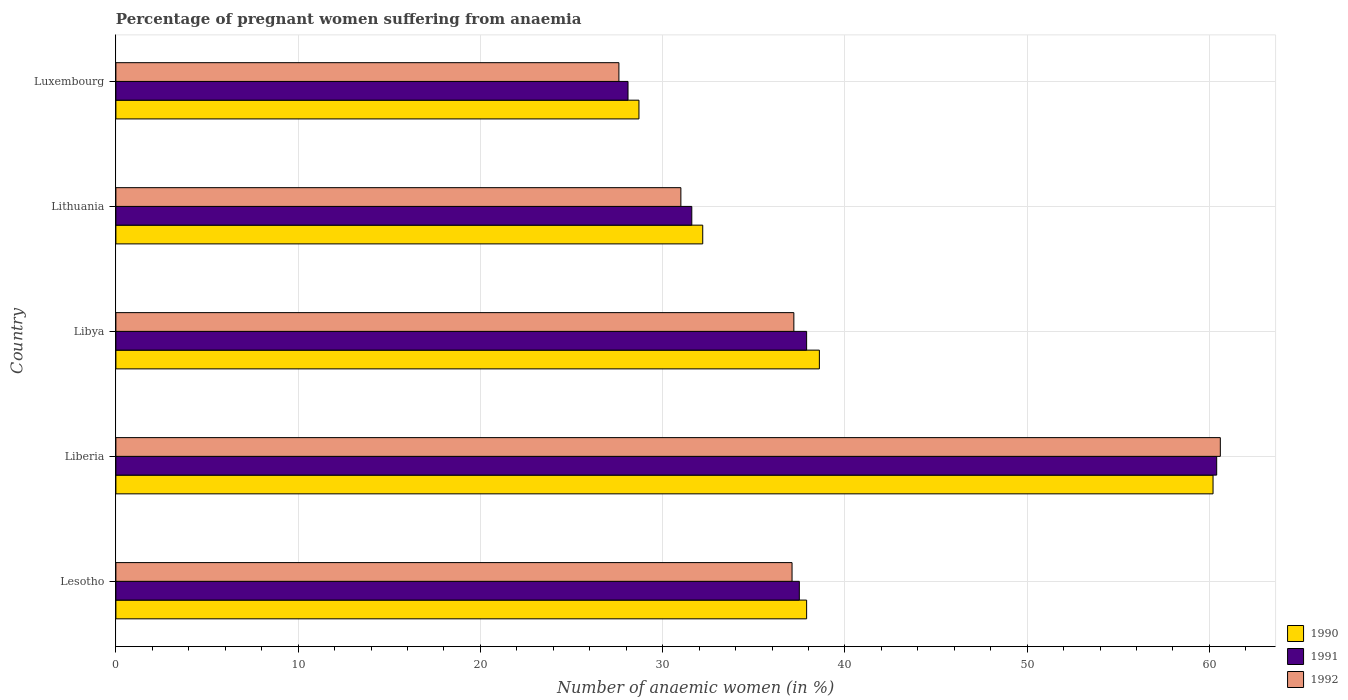How many different coloured bars are there?
Your answer should be compact. 3. How many groups of bars are there?
Provide a short and direct response. 5. How many bars are there on the 1st tick from the bottom?
Provide a short and direct response. 3. What is the label of the 1st group of bars from the top?
Offer a very short reply. Luxembourg. What is the number of anaemic women in 1991 in Lithuania?
Keep it short and to the point. 31.6. Across all countries, what is the maximum number of anaemic women in 1990?
Keep it short and to the point. 60.2. Across all countries, what is the minimum number of anaemic women in 1990?
Offer a terse response. 28.7. In which country was the number of anaemic women in 1991 maximum?
Make the answer very short. Liberia. In which country was the number of anaemic women in 1992 minimum?
Your answer should be very brief. Luxembourg. What is the total number of anaemic women in 1991 in the graph?
Make the answer very short. 195.5. What is the difference between the number of anaemic women in 1991 in Lesotho and that in Liberia?
Provide a succinct answer. -22.9. What is the difference between the number of anaemic women in 1990 in Libya and the number of anaemic women in 1992 in Lithuania?
Provide a short and direct response. 7.6. What is the average number of anaemic women in 1991 per country?
Ensure brevity in your answer.  39.1. What is the difference between the number of anaemic women in 1991 and number of anaemic women in 1990 in Lesotho?
Your answer should be compact. -0.4. What is the ratio of the number of anaemic women in 1991 in Lithuania to that in Luxembourg?
Offer a very short reply. 1.12. What is the difference between the highest and the second highest number of anaemic women in 1990?
Your answer should be very brief. 21.6. What is the difference between the highest and the lowest number of anaemic women in 1990?
Give a very brief answer. 31.5. What does the 1st bar from the top in Liberia represents?
Make the answer very short. 1992. Are all the bars in the graph horizontal?
Your answer should be very brief. Yes. Are the values on the major ticks of X-axis written in scientific E-notation?
Keep it short and to the point. No. How many legend labels are there?
Give a very brief answer. 3. What is the title of the graph?
Offer a very short reply. Percentage of pregnant women suffering from anaemia. Does "1976" appear as one of the legend labels in the graph?
Your response must be concise. No. What is the label or title of the X-axis?
Provide a short and direct response. Number of anaemic women (in %). What is the Number of anaemic women (in %) in 1990 in Lesotho?
Offer a terse response. 37.9. What is the Number of anaemic women (in %) in 1991 in Lesotho?
Provide a succinct answer. 37.5. What is the Number of anaemic women (in %) in 1992 in Lesotho?
Make the answer very short. 37.1. What is the Number of anaemic women (in %) in 1990 in Liberia?
Give a very brief answer. 60.2. What is the Number of anaemic women (in %) in 1991 in Liberia?
Keep it short and to the point. 60.4. What is the Number of anaemic women (in %) in 1992 in Liberia?
Provide a short and direct response. 60.6. What is the Number of anaemic women (in %) of 1990 in Libya?
Give a very brief answer. 38.6. What is the Number of anaemic women (in %) of 1991 in Libya?
Give a very brief answer. 37.9. What is the Number of anaemic women (in %) in 1992 in Libya?
Keep it short and to the point. 37.2. What is the Number of anaemic women (in %) in 1990 in Lithuania?
Make the answer very short. 32.2. What is the Number of anaemic women (in %) of 1991 in Lithuania?
Offer a terse response. 31.6. What is the Number of anaemic women (in %) in 1992 in Lithuania?
Your answer should be compact. 31. What is the Number of anaemic women (in %) of 1990 in Luxembourg?
Give a very brief answer. 28.7. What is the Number of anaemic women (in %) in 1991 in Luxembourg?
Your answer should be very brief. 28.1. What is the Number of anaemic women (in %) in 1992 in Luxembourg?
Make the answer very short. 27.6. Across all countries, what is the maximum Number of anaemic women (in %) in 1990?
Your answer should be compact. 60.2. Across all countries, what is the maximum Number of anaemic women (in %) of 1991?
Your answer should be compact. 60.4. Across all countries, what is the maximum Number of anaemic women (in %) in 1992?
Provide a succinct answer. 60.6. Across all countries, what is the minimum Number of anaemic women (in %) of 1990?
Your answer should be compact. 28.7. Across all countries, what is the minimum Number of anaemic women (in %) in 1991?
Provide a succinct answer. 28.1. Across all countries, what is the minimum Number of anaemic women (in %) of 1992?
Keep it short and to the point. 27.6. What is the total Number of anaemic women (in %) in 1990 in the graph?
Ensure brevity in your answer.  197.6. What is the total Number of anaemic women (in %) in 1991 in the graph?
Your answer should be very brief. 195.5. What is the total Number of anaemic women (in %) in 1992 in the graph?
Keep it short and to the point. 193.5. What is the difference between the Number of anaemic women (in %) in 1990 in Lesotho and that in Liberia?
Give a very brief answer. -22.3. What is the difference between the Number of anaemic women (in %) of 1991 in Lesotho and that in Liberia?
Offer a very short reply. -22.9. What is the difference between the Number of anaemic women (in %) in 1992 in Lesotho and that in Liberia?
Your answer should be compact. -23.5. What is the difference between the Number of anaemic women (in %) in 1990 in Lesotho and that in Libya?
Offer a terse response. -0.7. What is the difference between the Number of anaemic women (in %) in 1991 in Lesotho and that in Libya?
Offer a very short reply. -0.4. What is the difference between the Number of anaemic women (in %) in 1990 in Lesotho and that in Lithuania?
Give a very brief answer. 5.7. What is the difference between the Number of anaemic women (in %) in 1992 in Lesotho and that in Lithuania?
Make the answer very short. 6.1. What is the difference between the Number of anaemic women (in %) in 1992 in Lesotho and that in Luxembourg?
Your response must be concise. 9.5. What is the difference between the Number of anaemic women (in %) of 1990 in Liberia and that in Libya?
Give a very brief answer. 21.6. What is the difference between the Number of anaemic women (in %) in 1991 in Liberia and that in Libya?
Ensure brevity in your answer.  22.5. What is the difference between the Number of anaemic women (in %) in 1992 in Liberia and that in Libya?
Ensure brevity in your answer.  23.4. What is the difference between the Number of anaemic women (in %) of 1991 in Liberia and that in Lithuania?
Your answer should be very brief. 28.8. What is the difference between the Number of anaemic women (in %) of 1992 in Liberia and that in Lithuania?
Keep it short and to the point. 29.6. What is the difference between the Number of anaemic women (in %) of 1990 in Liberia and that in Luxembourg?
Your answer should be very brief. 31.5. What is the difference between the Number of anaemic women (in %) in 1991 in Liberia and that in Luxembourg?
Make the answer very short. 32.3. What is the difference between the Number of anaemic women (in %) in 1991 in Libya and that in Lithuania?
Provide a short and direct response. 6.3. What is the difference between the Number of anaemic women (in %) of 1990 in Libya and that in Luxembourg?
Your response must be concise. 9.9. What is the difference between the Number of anaemic women (in %) in 1991 in Libya and that in Luxembourg?
Your response must be concise. 9.8. What is the difference between the Number of anaemic women (in %) of 1992 in Libya and that in Luxembourg?
Give a very brief answer. 9.6. What is the difference between the Number of anaemic women (in %) in 1990 in Lithuania and that in Luxembourg?
Your response must be concise. 3.5. What is the difference between the Number of anaemic women (in %) of 1992 in Lithuania and that in Luxembourg?
Offer a terse response. 3.4. What is the difference between the Number of anaemic women (in %) in 1990 in Lesotho and the Number of anaemic women (in %) in 1991 in Liberia?
Offer a very short reply. -22.5. What is the difference between the Number of anaemic women (in %) in 1990 in Lesotho and the Number of anaemic women (in %) in 1992 in Liberia?
Provide a short and direct response. -22.7. What is the difference between the Number of anaemic women (in %) in 1991 in Lesotho and the Number of anaemic women (in %) in 1992 in Liberia?
Offer a very short reply. -23.1. What is the difference between the Number of anaemic women (in %) of 1990 in Lesotho and the Number of anaemic women (in %) of 1992 in Libya?
Give a very brief answer. 0.7. What is the difference between the Number of anaemic women (in %) of 1990 in Lesotho and the Number of anaemic women (in %) of 1991 in Lithuania?
Make the answer very short. 6.3. What is the difference between the Number of anaemic women (in %) of 1990 in Lesotho and the Number of anaemic women (in %) of 1991 in Luxembourg?
Offer a very short reply. 9.8. What is the difference between the Number of anaemic women (in %) of 1990 in Liberia and the Number of anaemic women (in %) of 1991 in Libya?
Your answer should be very brief. 22.3. What is the difference between the Number of anaemic women (in %) of 1990 in Liberia and the Number of anaemic women (in %) of 1992 in Libya?
Give a very brief answer. 23. What is the difference between the Number of anaemic women (in %) of 1991 in Liberia and the Number of anaemic women (in %) of 1992 in Libya?
Ensure brevity in your answer.  23.2. What is the difference between the Number of anaemic women (in %) of 1990 in Liberia and the Number of anaemic women (in %) of 1991 in Lithuania?
Provide a short and direct response. 28.6. What is the difference between the Number of anaemic women (in %) of 1990 in Liberia and the Number of anaemic women (in %) of 1992 in Lithuania?
Provide a succinct answer. 29.2. What is the difference between the Number of anaemic women (in %) in 1991 in Liberia and the Number of anaemic women (in %) in 1992 in Lithuania?
Your answer should be very brief. 29.4. What is the difference between the Number of anaemic women (in %) of 1990 in Liberia and the Number of anaemic women (in %) of 1991 in Luxembourg?
Your answer should be very brief. 32.1. What is the difference between the Number of anaemic women (in %) of 1990 in Liberia and the Number of anaemic women (in %) of 1992 in Luxembourg?
Keep it short and to the point. 32.6. What is the difference between the Number of anaemic women (in %) of 1991 in Liberia and the Number of anaemic women (in %) of 1992 in Luxembourg?
Your answer should be very brief. 32.8. What is the difference between the Number of anaemic women (in %) in 1991 in Libya and the Number of anaemic women (in %) in 1992 in Lithuania?
Make the answer very short. 6.9. What is the difference between the Number of anaemic women (in %) in 1991 in Libya and the Number of anaemic women (in %) in 1992 in Luxembourg?
Offer a terse response. 10.3. What is the difference between the Number of anaemic women (in %) in 1990 in Lithuania and the Number of anaemic women (in %) in 1991 in Luxembourg?
Your response must be concise. 4.1. What is the average Number of anaemic women (in %) of 1990 per country?
Offer a terse response. 39.52. What is the average Number of anaemic women (in %) of 1991 per country?
Your response must be concise. 39.1. What is the average Number of anaemic women (in %) of 1992 per country?
Give a very brief answer. 38.7. What is the difference between the Number of anaemic women (in %) in 1991 and Number of anaemic women (in %) in 1992 in Lesotho?
Offer a terse response. 0.4. What is the difference between the Number of anaemic women (in %) in 1990 and Number of anaemic women (in %) in 1992 in Liberia?
Your answer should be compact. -0.4. What is the difference between the Number of anaemic women (in %) in 1991 and Number of anaemic women (in %) in 1992 in Liberia?
Your answer should be very brief. -0.2. What is the difference between the Number of anaemic women (in %) of 1991 and Number of anaemic women (in %) of 1992 in Libya?
Your answer should be very brief. 0.7. What is the difference between the Number of anaemic women (in %) of 1990 and Number of anaemic women (in %) of 1991 in Lithuania?
Keep it short and to the point. 0.6. What is the difference between the Number of anaemic women (in %) of 1991 and Number of anaemic women (in %) of 1992 in Lithuania?
Your answer should be very brief. 0.6. What is the ratio of the Number of anaemic women (in %) of 1990 in Lesotho to that in Liberia?
Keep it short and to the point. 0.63. What is the ratio of the Number of anaemic women (in %) in 1991 in Lesotho to that in Liberia?
Offer a terse response. 0.62. What is the ratio of the Number of anaemic women (in %) of 1992 in Lesotho to that in Liberia?
Keep it short and to the point. 0.61. What is the ratio of the Number of anaemic women (in %) in 1990 in Lesotho to that in Libya?
Offer a very short reply. 0.98. What is the ratio of the Number of anaemic women (in %) of 1990 in Lesotho to that in Lithuania?
Your response must be concise. 1.18. What is the ratio of the Number of anaemic women (in %) in 1991 in Lesotho to that in Lithuania?
Offer a very short reply. 1.19. What is the ratio of the Number of anaemic women (in %) of 1992 in Lesotho to that in Lithuania?
Make the answer very short. 1.2. What is the ratio of the Number of anaemic women (in %) of 1990 in Lesotho to that in Luxembourg?
Your answer should be compact. 1.32. What is the ratio of the Number of anaemic women (in %) of 1991 in Lesotho to that in Luxembourg?
Keep it short and to the point. 1.33. What is the ratio of the Number of anaemic women (in %) of 1992 in Lesotho to that in Luxembourg?
Offer a terse response. 1.34. What is the ratio of the Number of anaemic women (in %) of 1990 in Liberia to that in Libya?
Keep it short and to the point. 1.56. What is the ratio of the Number of anaemic women (in %) of 1991 in Liberia to that in Libya?
Give a very brief answer. 1.59. What is the ratio of the Number of anaemic women (in %) of 1992 in Liberia to that in Libya?
Offer a terse response. 1.63. What is the ratio of the Number of anaemic women (in %) in 1990 in Liberia to that in Lithuania?
Give a very brief answer. 1.87. What is the ratio of the Number of anaemic women (in %) in 1991 in Liberia to that in Lithuania?
Provide a succinct answer. 1.91. What is the ratio of the Number of anaemic women (in %) of 1992 in Liberia to that in Lithuania?
Provide a succinct answer. 1.95. What is the ratio of the Number of anaemic women (in %) of 1990 in Liberia to that in Luxembourg?
Offer a very short reply. 2.1. What is the ratio of the Number of anaemic women (in %) in 1991 in Liberia to that in Luxembourg?
Your response must be concise. 2.15. What is the ratio of the Number of anaemic women (in %) of 1992 in Liberia to that in Luxembourg?
Ensure brevity in your answer.  2.2. What is the ratio of the Number of anaemic women (in %) in 1990 in Libya to that in Lithuania?
Ensure brevity in your answer.  1.2. What is the ratio of the Number of anaemic women (in %) of 1991 in Libya to that in Lithuania?
Your answer should be very brief. 1.2. What is the ratio of the Number of anaemic women (in %) of 1990 in Libya to that in Luxembourg?
Keep it short and to the point. 1.34. What is the ratio of the Number of anaemic women (in %) of 1991 in Libya to that in Luxembourg?
Make the answer very short. 1.35. What is the ratio of the Number of anaemic women (in %) in 1992 in Libya to that in Luxembourg?
Provide a succinct answer. 1.35. What is the ratio of the Number of anaemic women (in %) of 1990 in Lithuania to that in Luxembourg?
Offer a terse response. 1.12. What is the ratio of the Number of anaemic women (in %) in 1991 in Lithuania to that in Luxembourg?
Provide a succinct answer. 1.12. What is the ratio of the Number of anaemic women (in %) of 1992 in Lithuania to that in Luxembourg?
Provide a short and direct response. 1.12. What is the difference between the highest and the second highest Number of anaemic women (in %) in 1990?
Your response must be concise. 21.6. What is the difference between the highest and the second highest Number of anaemic women (in %) in 1992?
Offer a very short reply. 23.4. What is the difference between the highest and the lowest Number of anaemic women (in %) in 1990?
Make the answer very short. 31.5. What is the difference between the highest and the lowest Number of anaemic women (in %) of 1991?
Your answer should be compact. 32.3. What is the difference between the highest and the lowest Number of anaemic women (in %) of 1992?
Keep it short and to the point. 33. 